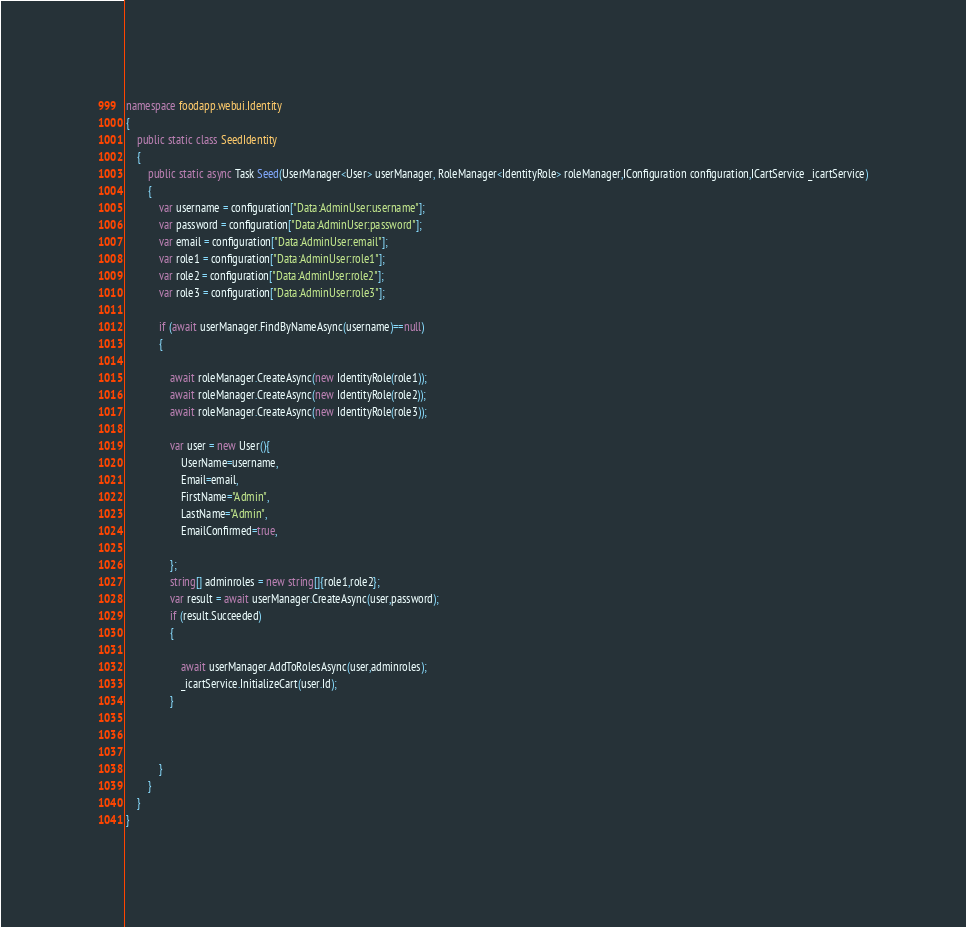<code> <loc_0><loc_0><loc_500><loc_500><_C#_>namespace foodapp.webui.Identity
{
    public static class SeedIdentity
    {
        public static async Task Seed(UserManager<User> userManager, RoleManager<IdentityRole> roleManager,IConfiguration configuration,ICartService _icartService)
        {
            var username = configuration["Data:AdminUser:username"];
            var password = configuration["Data:AdminUser:password"];
            var email = configuration["Data:AdminUser:email"];
            var role1 = configuration["Data:AdminUser:role1"];
            var role2 = configuration["Data:AdminUser:role2"];
            var role3 = configuration["Data:AdminUser:role3"];

            if (await userManager.FindByNameAsync(username)==null)
            {
                
                await roleManager.CreateAsync(new IdentityRole(role1));
                await roleManager.CreateAsync(new IdentityRole(role2));
                await roleManager.CreateAsync(new IdentityRole(role3));

                var user = new User(){
                    UserName=username,
                    Email=email,
                    FirstName="Admin",
                    LastName="Admin",
                    EmailConfirmed=true,

                };
                string[] adminroles = new string[]{role1,role2};
                var result = await userManager.CreateAsync(user,password);
                if (result.Succeeded)
                {
                    
                    await userManager.AddToRolesAsync(user,adminroles);
                    _icartService.InitializeCart(user.Id);
                }

                
                
            }
        }
    }
}</code> 